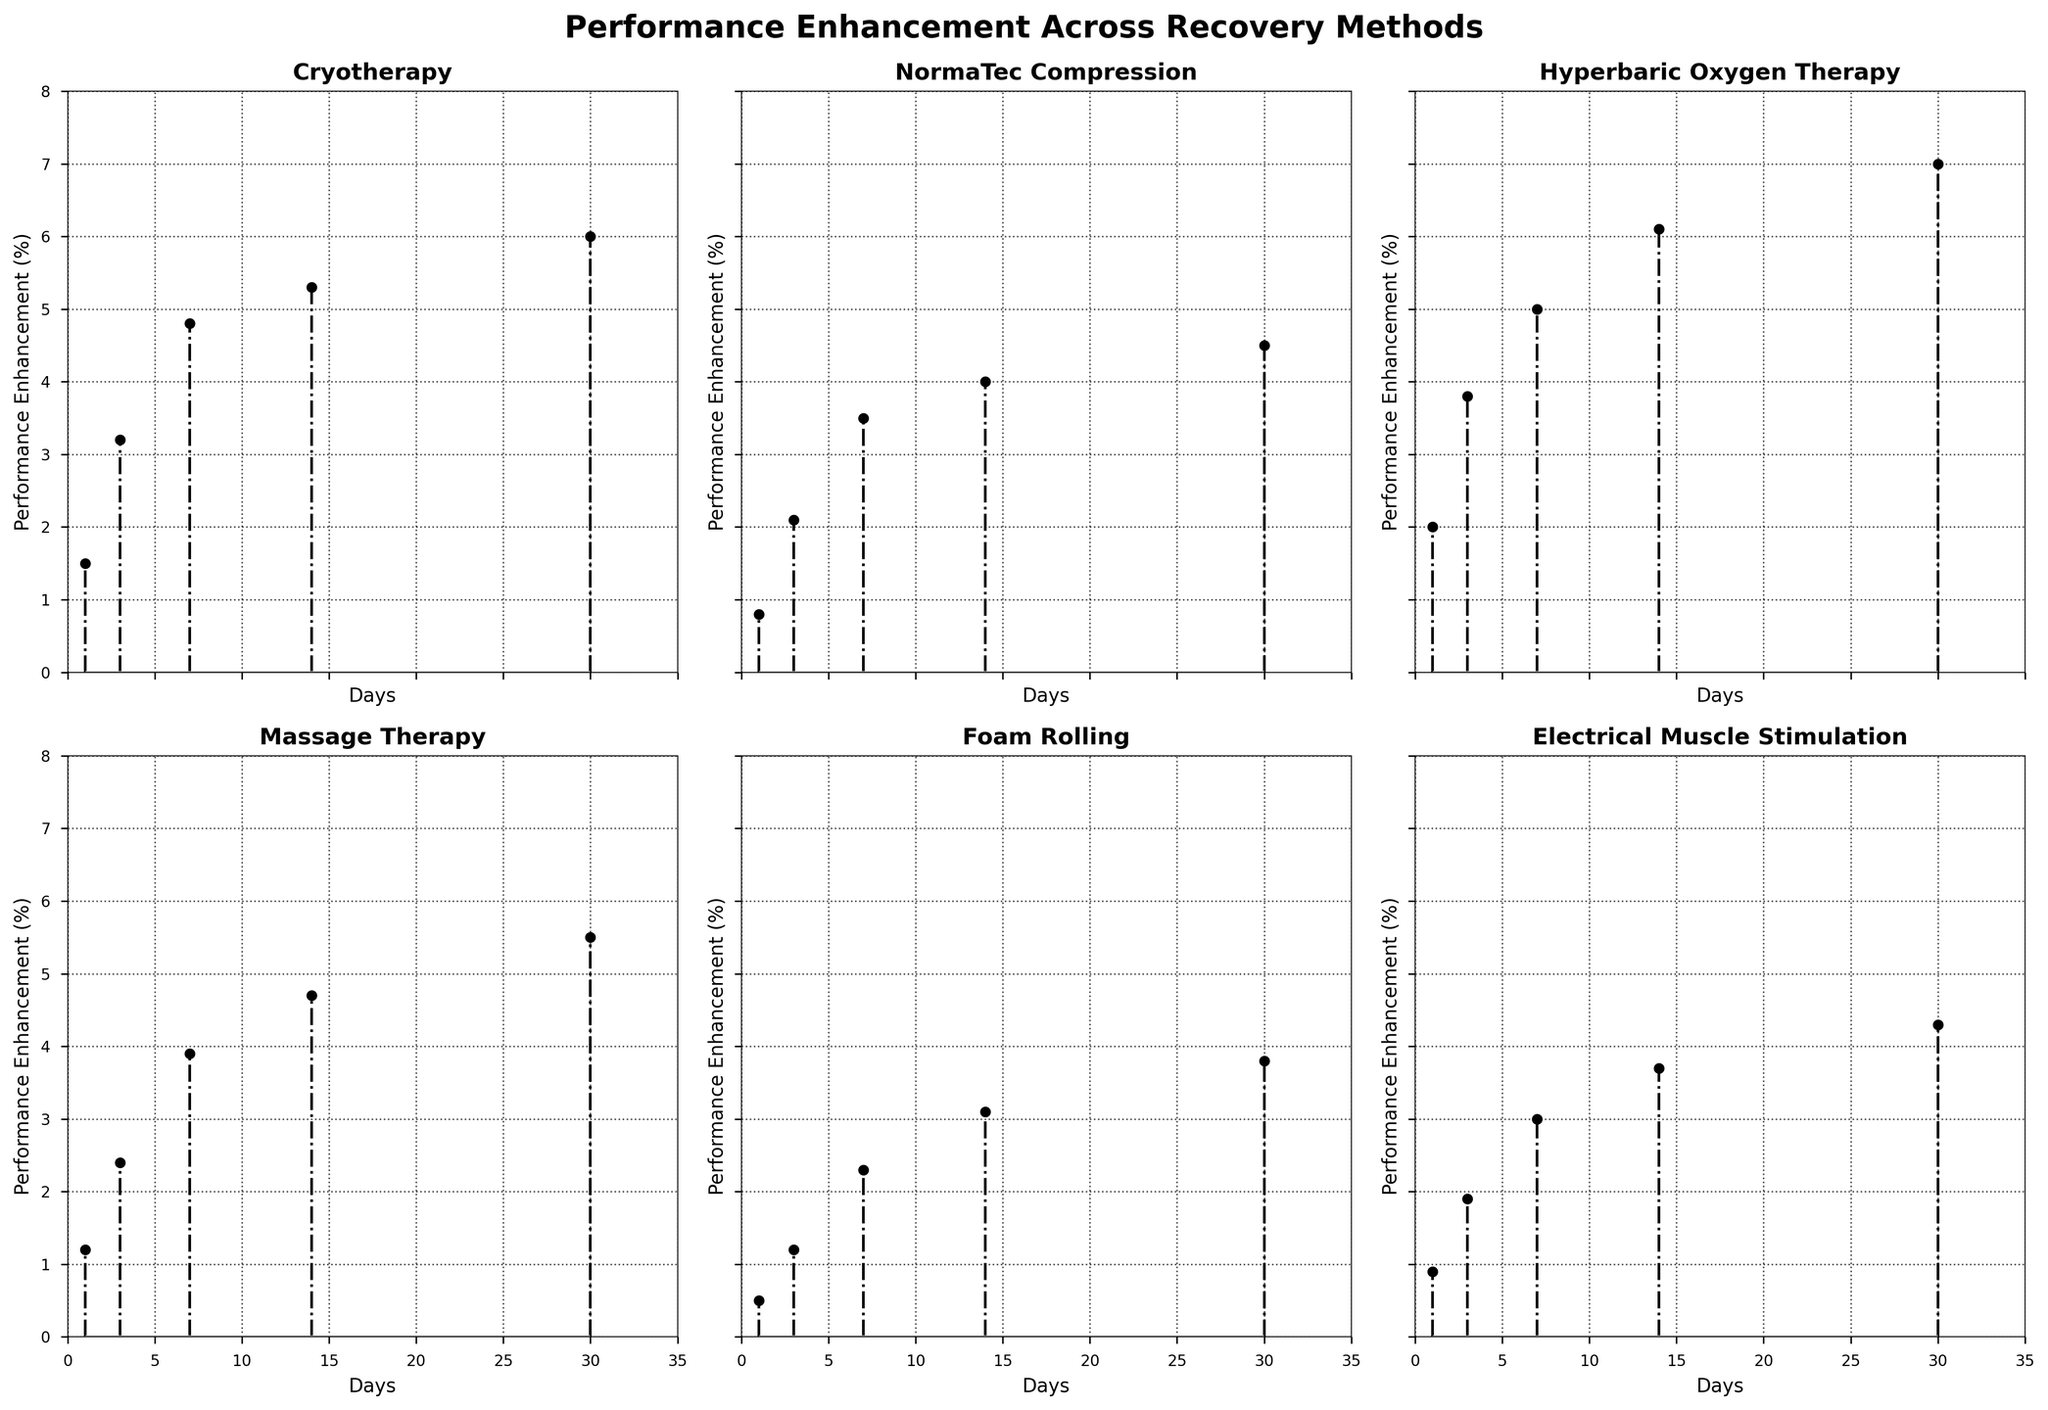What recovery method shows the highest performance enhancement after 30 days? Hyperbaric Oxygen Therapy shows the highest performance enhancement after 30 days, with a value of 7.0%. Look at the performance enhancement values for Day 30 in each subplot.
Answer: Hyperbaric Oxygen Therapy How does the performance enhancement of Cryotherapy compare to Massage Therapy after 7 days? Cryotherapy has a performance enhancement of 4.8% after 7 days, while Massage Therapy has 3.9%. Look at the values for Day 7 in the subplots for Cryotherapy and Massage Therapy.
Answer: Cryotherapy: 4.8%, Massage Therapy: 3.9% What is the trend in performance enhancement for NormaTec Compression over the 30 days? NormaTec Compression shows a consistent increase in performance enhancement from 0.8% on Day 1 to 4.5% on Day 30. Examine the plotted points in the NormaTec Compression subplot to see the increasing trend.
Answer: Consistent increase from 0.8% to 4.5% Which recovery method shows the least improvement on Day 1? Foam Rolling shows the least improvement on Day 1, with a performance enhancement of 0.5%. Read the performance enhancement values for Day 1 in each subplot.
Answer: Foam Rolling Calculating the average performance enhancement for Electrical Muscle Stimulation over the 30 days, what is the result? Sum the values of Electrical Muscle Stimulation (0.9, 1.9, 3.0, 3.7, 4.3) and divide by 5. (0.9 + 1.9 + 3.0 + 3.7 + 4.3 = 13.8, 13.8/5 = 2.76).
Answer: 2.76 Across all methods, which day shows the greatest increase in performance enhancement for Hyperbaric Oxygen Therapy? Hyperbaric Oxygen Therapy shows the greatest increase on Day 14 with a value of 6.1%. Identify the highest values across the days for Hyperbaric Oxygen Therapy and compare.
Answer: Day 14 (6.1%) Describe the general pattern of performance enhancement in the Cryotherapy subplot. In the Cryotherapy subplot, performance enhancement increases steadily from 1.5% on Day 1 to 6.0% on Day 30, suggesting an upward trend. Examine the plotted points to observe the consistent rise.
Answer: Steady increase from 1.5% to 6.0% Comparing Day 3, which method has the least performance enhancement and what is that value? For Day 3, Foam Rolling has the least performance enhancement with a value of 1.2%. Check the performance enhancement values for Day 3 across all subplots.
Answer: Foam Rolling (1.2%) What is the difference in performance enhancement between Electrical Muscle Stimulation and Foam Rolling on Day 14? Electrical Muscle Stimulation has an enhancement of 3.7% on Day 14, while Foam Rolling has 3.1%. The difference is 3.7% - 3.1% = 0.6%. Subtract the Day 14 values for the two methods.
Answer: 0.6% Which method has the steepest improvement rate between Day 1 and Day 7? Hyperbaric Oxygen Therapy increases from 2.0% on Day 1 to 5.0% on Day 7, an improvement of 3.0%. Compare the rate of increase between Day 1 and Day 7 for all methods to find the steepest.
Answer: Hyperbaric Oxygen Therapy (3.0% improvement) 